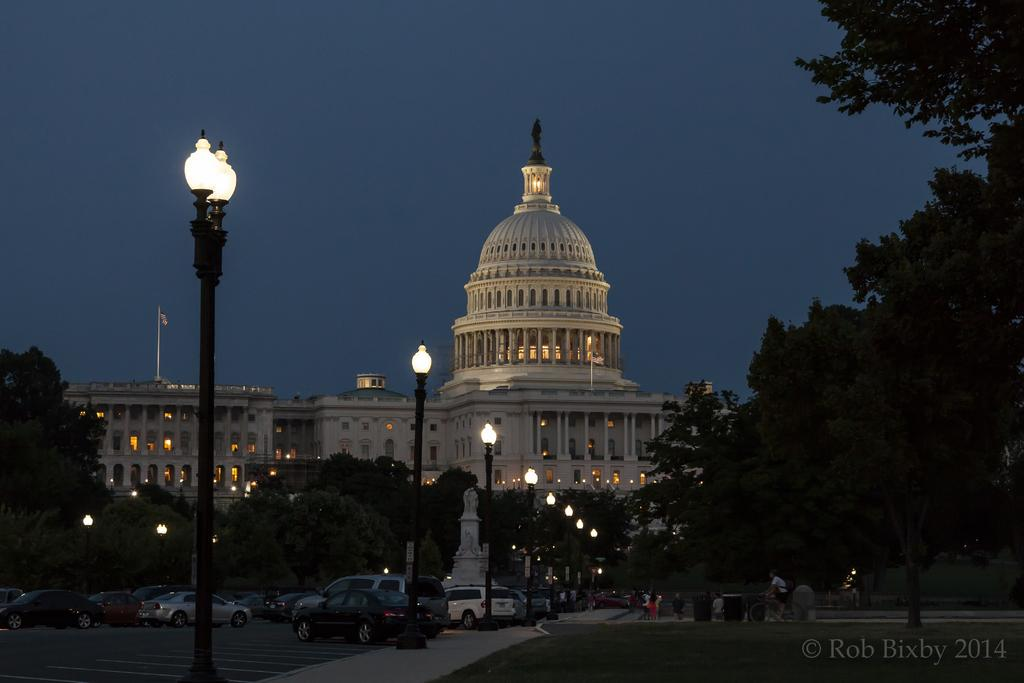What type of structure is visible in the image? There is a building in the image. What else can be seen in the image besides the building? There are poles, cars on the road, people, trees in the background, and the sky visible in the background. Can you describe the vehicles in the image? There are cars on the road in the image. What type of natural elements are present in the image? There are trees in the background of the image. What type of poison is being used by the people in the image? There is no poison present in the image; it features a building, poles, cars, people, trees, and the sky. 